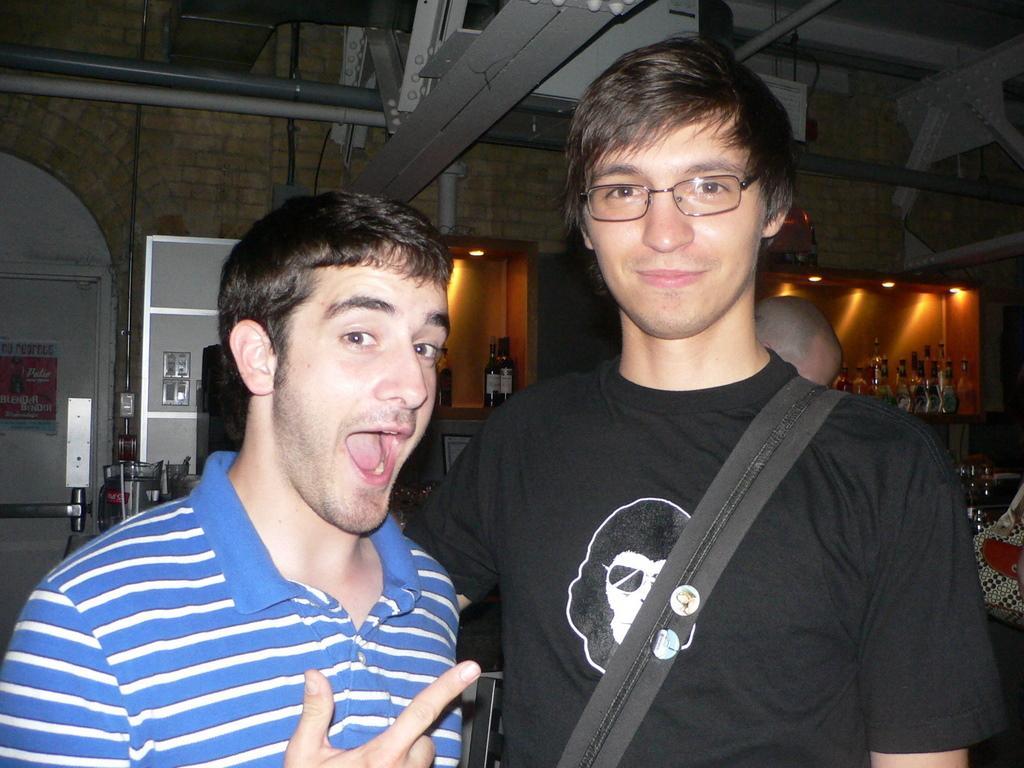Please provide a concise description of this image. In this image I can see a person wearing black colored t shirt and another person wearing blue and white colored t shirt are standing. In the background I can see the wall, few bottles in the racks, few lights, few pipes which are grey and white in color and a poster attached to the door. 